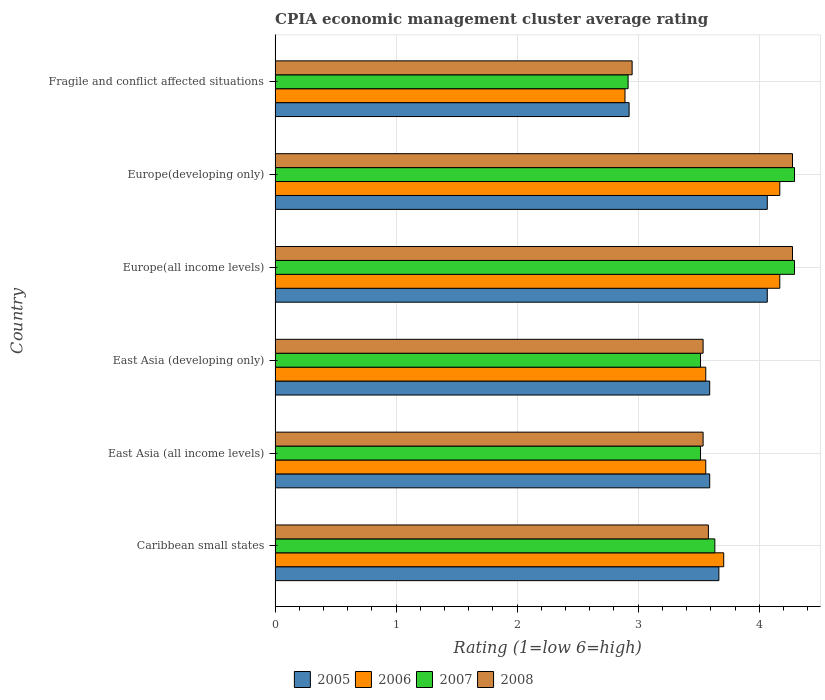How many different coloured bars are there?
Make the answer very short. 4. How many groups of bars are there?
Give a very brief answer. 6. Are the number of bars on each tick of the Y-axis equal?
Give a very brief answer. Yes. How many bars are there on the 4th tick from the top?
Your answer should be very brief. 4. How many bars are there on the 2nd tick from the bottom?
Make the answer very short. 4. What is the label of the 3rd group of bars from the top?
Provide a succinct answer. Europe(all income levels). In how many cases, is the number of bars for a given country not equal to the number of legend labels?
Make the answer very short. 0. What is the CPIA rating in 2008 in Europe(all income levels)?
Provide a succinct answer. 4.28. Across all countries, what is the maximum CPIA rating in 2005?
Keep it short and to the point. 4.07. Across all countries, what is the minimum CPIA rating in 2007?
Make the answer very short. 2.92. In which country was the CPIA rating in 2005 maximum?
Offer a very short reply. Europe(all income levels). In which country was the CPIA rating in 2008 minimum?
Give a very brief answer. Fragile and conflict affected situations. What is the total CPIA rating in 2008 in the graph?
Provide a short and direct response. 22.15. What is the difference between the CPIA rating in 2008 in Caribbean small states and the CPIA rating in 2007 in Europe(developing only)?
Make the answer very short. -0.71. What is the average CPIA rating in 2005 per country?
Offer a terse response. 3.65. What is the difference between the CPIA rating in 2006 and CPIA rating in 2005 in Caribbean small states?
Provide a succinct answer. 0.04. In how many countries, is the CPIA rating in 2008 greater than 3.6 ?
Provide a succinct answer. 2. What is the ratio of the CPIA rating in 2005 in East Asia (all income levels) to that in Europe(developing only)?
Ensure brevity in your answer.  0.88. Is the CPIA rating in 2006 in Caribbean small states less than that in Europe(developing only)?
Ensure brevity in your answer.  Yes. What is the difference between the highest and the lowest CPIA rating in 2008?
Keep it short and to the point. 1.33. Is the sum of the CPIA rating in 2006 in Europe(all income levels) and Fragile and conflict affected situations greater than the maximum CPIA rating in 2008 across all countries?
Offer a terse response. Yes. Is it the case that in every country, the sum of the CPIA rating in 2007 and CPIA rating in 2008 is greater than the CPIA rating in 2006?
Keep it short and to the point. Yes. Are all the bars in the graph horizontal?
Provide a succinct answer. Yes. How many countries are there in the graph?
Your response must be concise. 6. What is the difference between two consecutive major ticks on the X-axis?
Provide a succinct answer. 1. Are the values on the major ticks of X-axis written in scientific E-notation?
Offer a terse response. No. Does the graph contain grids?
Offer a terse response. Yes. Where does the legend appear in the graph?
Offer a very short reply. Bottom center. How many legend labels are there?
Your answer should be very brief. 4. How are the legend labels stacked?
Offer a very short reply. Horizontal. What is the title of the graph?
Make the answer very short. CPIA economic management cluster average rating. Does "2011" appear as one of the legend labels in the graph?
Keep it short and to the point. No. What is the label or title of the X-axis?
Give a very brief answer. Rating (1=low 6=high). What is the Rating (1=low 6=high) in 2005 in Caribbean small states?
Provide a succinct answer. 3.67. What is the Rating (1=low 6=high) in 2006 in Caribbean small states?
Your answer should be compact. 3.71. What is the Rating (1=low 6=high) in 2007 in Caribbean small states?
Provide a succinct answer. 3.63. What is the Rating (1=low 6=high) in 2008 in Caribbean small states?
Offer a terse response. 3.58. What is the Rating (1=low 6=high) in 2005 in East Asia (all income levels)?
Offer a very short reply. 3.59. What is the Rating (1=low 6=high) in 2006 in East Asia (all income levels)?
Offer a terse response. 3.56. What is the Rating (1=low 6=high) in 2007 in East Asia (all income levels)?
Ensure brevity in your answer.  3.52. What is the Rating (1=low 6=high) of 2008 in East Asia (all income levels)?
Your answer should be very brief. 3.54. What is the Rating (1=low 6=high) of 2005 in East Asia (developing only)?
Offer a very short reply. 3.59. What is the Rating (1=low 6=high) of 2006 in East Asia (developing only)?
Ensure brevity in your answer.  3.56. What is the Rating (1=low 6=high) in 2007 in East Asia (developing only)?
Offer a very short reply. 3.52. What is the Rating (1=low 6=high) of 2008 in East Asia (developing only)?
Provide a succinct answer. 3.54. What is the Rating (1=low 6=high) of 2005 in Europe(all income levels)?
Your answer should be compact. 4.07. What is the Rating (1=low 6=high) of 2006 in Europe(all income levels)?
Offer a terse response. 4.17. What is the Rating (1=low 6=high) of 2007 in Europe(all income levels)?
Your answer should be very brief. 4.29. What is the Rating (1=low 6=high) in 2008 in Europe(all income levels)?
Make the answer very short. 4.28. What is the Rating (1=low 6=high) of 2005 in Europe(developing only)?
Your answer should be very brief. 4.07. What is the Rating (1=low 6=high) of 2006 in Europe(developing only)?
Your answer should be very brief. 4.17. What is the Rating (1=low 6=high) of 2007 in Europe(developing only)?
Offer a very short reply. 4.29. What is the Rating (1=low 6=high) of 2008 in Europe(developing only)?
Your answer should be very brief. 4.28. What is the Rating (1=low 6=high) in 2005 in Fragile and conflict affected situations?
Keep it short and to the point. 2.92. What is the Rating (1=low 6=high) of 2006 in Fragile and conflict affected situations?
Your answer should be very brief. 2.89. What is the Rating (1=low 6=high) in 2007 in Fragile and conflict affected situations?
Provide a succinct answer. 2.92. What is the Rating (1=low 6=high) in 2008 in Fragile and conflict affected situations?
Provide a short and direct response. 2.95. Across all countries, what is the maximum Rating (1=low 6=high) in 2005?
Offer a very short reply. 4.07. Across all countries, what is the maximum Rating (1=low 6=high) in 2006?
Provide a short and direct response. 4.17. Across all countries, what is the maximum Rating (1=low 6=high) of 2007?
Provide a succinct answer. 4.29. Across all countries, what is the maximum Rating (1=low 6=high) of 2008?
Give a very brief answer. 4.28. Across all countries, what is the minimum Rating (1=low 6=high) of 2005?
Your answer should be compact. 2.92. Across all countries, what is the minimum Rating (1=low 6=high) of 2006?
Offer a very short reply. 2.89. Across all countries, what is the minimum Rating (1=low 6=high) of 2007?
Your answer should be very brief. 2.92. Across all countries, what is the minimum Rating (1=low 6=high) in 2008?
Ensure brevity in your answer.  2.95. What is the total Rating (1=low 6=high) in 2005 in the graph?
Your response must be concise. 21.91. What is the total Rating (1=low 6=high) of 2006 in the graph?
Offer a terse response. 22.05. What is the total Rating (1=low 6=high) in 2007 in the graph?
Your response must be concise. 22.16. What is the total Rating (1=low 6=high) of 2008 in the graph?
Your answer should be very brief. 22.15. What is the difference between the Rating (1=low 6=high) in 2005 in Caribbean small states and that in East Asia (all income levels)?
Your answer should be very brief. 0.08. What is the difference between the Rating (1=low 6=high) of 2006 in Caribbean small states and that in East Asia (all income levels)?
Provide a short and direct response. 0.15. What is the difference between the Rating (1=low 6=high) of 2007 in Caribbean small states and that in East Asia (all income levels)?
Your response must be concise. 0.12. What is the difference between the Rating (1=low 6=high) of 2008 in Caribbean small states and that in East Asia (all income levels)?
Give a very brief answer. 0.04. What is the difference between the Rating (1=low 6=high) of 2005 in Caribbean small states and that in East Asia (developing only)?
Keep it short and to the point. 0.08. What is the difference between the Rating (1=low 6=high) in 2006 in Caribbean small states and that in East Asia (developing only)?
Your response must be concise. 0.15. What is the difference between the Rating (1=low 6=high) of 2007 in Caribbean small states and that in East Asia (developing only)?
Offer a very short reply. 0.12. What is the difference between the Rating (1=low 6=high) in 2008 in Caribbean small states and that in East Asia (developing only)?
Provide a short and direct response. 0.04. What is the difference between the Rating (1=low 6=high) in 2006 in Caribbean small states and that in Europe(all income levels)?
Provide a succinct answer. -0.46. What is the difference between the Rating (1=low 6=high) of 2007 in Caribbean small states and that in Europe(all income levels)?
Your answer should be very brief. -0.66. What is the difference between the Rating (1=low 6=high) of 2008 in Caribbean small states and that in Europe(all income levels)?
Your response must be concise. -0.69. What is the difference between the Rating (1=low 6=high) of 2006 in Caribbean small states and that in Europe(developing only)?
Provide a short and direct response. -0.46. What is the difference between the Rating (1=low 6=high) of 2007 in Caribbean small states and that in Europe(developing only)?
Ensure brevity in your answer.  -0.66. What is the difference between the Rating (1=low 6=high) of 2008 in Caribbean small states and that in Europe(developing only)?
Keep it short and to the point. -0.69. What is the difference between the Rating (1=low 6=high) in 2005 in Caribbean small states and that in Fragile and conflict affected situations?
Make the answer very short. 0.74. What is the difference between the Rating (1=low 6=high) in 2006 in Caribbean small states and that in Fragile and conflict affected situations?
Make the answer very short. 0.82. What is the difference between the Rating (1=low 6=high) of 2007 in Caribbean small states and that in Fragile and conflict affected situations?
Provide a short and direct response. 0.72. What is the difference between the Rating (1=low 6=high) of 2008 in Caribbean small states and that in Fragile and conflict affected situations?
Keep it short and to the point. 0.63. What is the difference between the Rating (1=low 6=high) of 2006 in East Asia (all income levels) and that in East Asia (developing only)?
Make the answer very short. 0. What is the difference between the Rating (1=low 6=high) in 2007 in East Asia (all income levels) and that in East Asia (developing only)?
Offer a very short reply. 0. What is the difference between the Rating (1=low 6=high) of 2005 in East Asia (all income levels) and that in Europe(all income levels)?
Keep it short and to the point. -0.48. What is the difference between the Rating (1=low 6=high) of 2006 in East Asia (all income levels) and that in Europe(all income levels)?
Provide a succinct answer. -0.61. What is the difference between the Rating (1=low 6=high) in 2007 in East Asia (all income levels) and that in Europe(all income levels)?
Make the answer very short. -0.78. What is the difference between the Rating (1=low 6=high) in 2008 in East Asia (all income levels) and that in Europe(all income levels)?
Provide a succinct answer. -0.74. What is the difference between the Rating (1=low 6=high) of 2005 in East Asia (all income levels) and that in Europe(developing only)?
Provide a short and direct response. -0.48. What is the difference between the Rating (1=low 6=high) in 2006 in East Asia (all income levels) and that in Europe(developing only)?
Provide a succinct answer. -0.61. What is the difference between the Rating (1=low 6=high) of 2007 in East Asia (all income levels) and that in Europe(developing only)?
Offer a very short reply. -0.78. What is the difference between the Rating (1=low 6=high) of 2008 in East Asia (all income levels) and that in Europe(developing only)?
Provide a short and direct response. -0.74. What is the difference between the Rating (1=low 6=high) of 2005 in East Asia (all income levels) and that in Fragile and conflict affected situations?
Offer a terse response. 0.67. What is the difference between the Rating (1=low 6=high) of 2006 in East Asia (all income levels) and that in Fragile and conflict affected situations?
Give a very brief answer. 0.67. What is the difference between the Rating (1=low 6=high) of 2007 in East Asia (all income levels) and that in Fragile and conflict affected situations?
Keep it short and to the point. 0.6. What is the difference between the Rating (1=low 6=high) in 2008 in East Asia (all income levels) and that in Fragile and conflict affected situations?
Keep it short and to the point. 0.59. What is the difference between the Rating (1=low 6=high) in 2005 in East Asia (developing only) and that in Europe(all income levels)?
Keep it short and to the point. -0.48. What is the difference between the Rating (1=low 6=high) of 2006 in East Asia (developing only) and that in Europe(all income levels)?
Your answer should be compact. -0.61. What is the difference between the Rating (1=low 6=high) in 2007 in East Asia (developing only) and that in Europe(all income levels)?
Your answer should be very brief. -0.78. What is the difference between the Rating (1=low 6=high) of 2008 in East Asia (developing only) and that in Europe(all income levels)?
Offer a very short reply. -0.74. What is the difference between the Rating (1=low 6=high) in 2005 in East Asia (developing only) and that in Europe(developing only)?
Ensure brevity in your answer.  -0.48. What is the difference between the Rating (1=low 6=high) of 2006 in East Asia (developing only) and that in Europe(developing only)?
Give a very brief answer. -0.61. What is the difference between the Rating (1=low 6=high) in 2007 in East Asia (developing only) and that in Europe(developing only)?
Your answer should be compact. -0.78. What is the difference between the Rating (1=low 6=high) in 2008 in East Asia (developing only) and that in Europe(developing only)?
Make the answer very short. -0.74. What is the difference between the Rating (1=low 6=high) in 2005 in East Asia (developing only) and that in Fragile and conflict affected situations?
Provide a succinct answer. 0.67. What is the difference between the Rating (1=low 6=high) in 2006 in East Asia (developing only) and that in Fragile and conflict affected situations?
Provide a short and direct response. 0.67. What is the difference between the Rating (1=low 6=high) in 2007 in East Asia (developing only) and that in Fragile and conflict affected situations?
Ensure brevity in your answer.  0.6. What is the difference between the Rating (1=low 6=high) in 2008 in East Asia (developing only) and that in Fragile and conflict affected situations?
Your response must be concise. 0.59. What is the difference between the Rating (1=low 6=high) of 2005 in Europe(all income levels) and that in Europe(developing only)?
Ensure brevity in your answer.  0. What is the difference between the Rating (1=low 6=high) in 2008 in Europe(all income levels) and that in Europe(developing only)?
Make the answer very short. 0. What is the difference between the Rating (1=low 6=high) of 2005 in Europe(all income levels) and that in Fragile and conflict affected situations?
Ensure brevity in your answer.  1.14. What is the difference between the Rating (1=low 6=high) of 2006 in Europe(all income levels) and that in Fragile and conflict affected situations?
Make the answer very short. 1.28. What is the difference between the Rating (1=low 6=high) in 2007 in Europe(all income levels) and that in Fragile and conflict affected situations?
Your answer should be very brief. 1.38. What is the difference between the Rating (1=low 6=high) of 2008 in Europe(all income levels) and that in Fragile and conflict affected situations?
Ensure brevity in your answer.  1.32. What is the difference between the Rating (1=low 6=high) in 2005 in Europe(developing only) and that in Fragile and conflict affected situations?
Provide a short and direct response. 1.14. What is the difference between the Rating (1=low 6=high) in 2006 in Europe(developing only) and that in Fragile and conflict affected situations?
Provide a succinct answer. 1.28. What is the difference between the Rating (1=low 6=high) in 2007 in Europe(developing only) and that in Fragile and conflict affected situations?
Offer a terse response. 1.38. What is the difference between the Rating (1=low 6=high) in 2008 in Europe(developing only) and that in Fragile and conflict affected situations?
Provide a succinct answer. 1.32. What is the difference between the Rating (1=low 6=high) in 2005 in Caribbean small states and the Rating (1=low 6=high) in 2006 in East Asia (all income levels)?
Offer a very short reply. 0.11. What is the difference between the Rating (1=low 6=high) in 2005 in Caribbean small states and the Rating (1=low 6=high) in 2007 in East Asia (all income levels)?
Offer a terse response. 0.15. What is the difference between the Rating (1=low 6=high) in 2005 in Caribbean small states and the Rating (1=low 6=high) in 2008 in East Asia (all income levels)?
Provide a succinct answer. 0.13. What is the difference between the Rating (1=low 6=high) of 2006 in Caribbean small states and the Rating (1=low 6=high) of 2007 in East Asia (all income levels)?
Provide a short and direct response. 0.19. What is the difference between the Rating (1=low 6=high) of 2006 in Caribbean small states and the Rating (1=low 6=high) of 2008 in East Asia (all income levels)?
Make the answer very short. 0.17. What is the difference between the Rating (1=low 6=high) of 2007 in Caribbean small states and the Rating (1=low 6=high) of 2008 in East Asia (all income levels)?
Keep it short and to the point. 0.1. What is the difference between the Rating (1=low 6=high) of 2005 in Caribbean small states and the Rating (1=low 6=high) of 2006 in East Asia (developing only)?
Offer a terse response. 0.11. What is the difference between the Rating (1=low 6=high) in 2005 in Caribbean small states and the Rating (1=low 6=high) in 2007 in East Asia (developing only)?
Your answer should be compact. 0.15. What is the difference between the Rating (1=low 6=high) of 2005 in Caribbean small states and the Rating (1=low 6=high) of 2008 in East Asia (developing only)?
Your response must be concise. 0.13. What is the difference between the Rating (1=low 6=high) in 2006 in Caribbean small states and the Rating (1=low 6=high) in 2007 in East Asia (developing only)?
Provide a succinct answer. 0.19. What is the difference between the Rating (1=low 6=high) in 2006 in Caribbean small states and the Rating (1=low 6=high) in 2008 in East Asia (developing only)?
Offer a terse response. 0.17. What is the difference between the Rating (1=low 6=high) in 2007 in Caribbean small states and the Rating (1=low 6=high) in 2008 in East Asia (developing only)?
Your answer should be compact. 0.1. What is the difference between the Rating (1=low 6=high) in 2005 in Caribbean small states and the Rating (1=low 6=high) in 2006 in Europe(all income levels)?
Your answer should be compact. -0.5. What is the difference between the Rating (1=low 6=high) in 2005 in Caribbean small states and the Rating (1=low 6=high) in 2007 in Europe(all income levels)?
Your answer should be very brief. -0.62. What is the difference between the Rating (1=low 6=high) in 2005 in Caribbean small states and the Rating (1=low 6=high) in 2008 in Europe(all income levels)?
Your answer should be compact. -0.61. What is the difference between the Rating (1=low 6=high) in 2006 in Caribbean small states and the Rating (1=low 6=high) in 2007 in Europe(all income levels)?
Make the answer very short. -0.58. What is the difference between the Rating (1=low 6=high) in 2006 in Caribbean small states and the Rating (1=low 6=high) in 2008 in Europe(all income levels)?
Offer a terse response. -0.57. What is the difference between the Rating (1=low 6=high) in 2007 in Caribbean small states and the Rating (1=low 6=high) in 2008 in Europe(all income levels)?
Your answer should be very brief. -0.64. What is the difference between the Rating (1=low 6=high) in 2005 in Caribbean small states and the Rating (1=low 6=high) in 2006 in Europe(developing only)?
Your answer should be very brief. -0.5. What is the difference between the Rating (1=low 6=high) in 2005 in Caribbean small states and the Rating (1=low 6=high) in 2007 in Europe(developing only)?
Offer a terse response. -0.62. What is the difference between the Rating (1=low 6=high) of 2005 in Caribbean small states and the Rating (1=low 6=high) of 2008 in Europe(developing only)?
Your response must be concise. -0.61. What is the difference between the Rating (1=low 6=high) of 2006 in Caribbean small states and the Rating (1=low 6=high) of 2007 in Europe(developing only)?
Keep it short and to the point. -0.58. What is the difference between the Rating (1=low 6=high) of 2006 in Caribbean small states and the Rating (1=low 6=high) of 2008 in Europe(developing only)?
Your answer should be very brief. -0.57. What is the difference between the Rating (1=low 6=high) in 2007 in Caribbean small states and the Rating (1=low 6=high) in 2008 in Europe(developing only)?
Provide a succinct answer. -0.64. What is the difference between the Rating (1=low 6=high) of 2005 in Caribbean small states and the Rating (1=low 6=high) of 2006 in Fragile and conflict affected situations?
Keep it short and to the point. 0.78. What is the difference between the Rating (1=low 6=high) in 2005 in Caribbean small states and the Rating (1=low 6=high) in 2007 in Fragile and conflict affected situations?
Provide a short and direct response. 0.75. What is the difference between the Rating (1=low 6=high) in 2005 in Caribbean small states and the Rating (1=low 6=high) in 2008 in Fragile and conflict affected situations?
Ensure brevity in your answer.  0.72. What is the difference between the Rating (1=low 6=high) in 2006 in Caribbean small states and the Rating (1=low 6=high) in 2007 in Fragile and conflict affected situations?
Ensure brevity in your answer.  0.79. What is the difference between the Rating (1=low 6=high) of 2006 in Caribbean small states and the Rating (1=low 6=high) of 2008 in Fragile and conflict affected situations?
Keep it short and to the point. 0.76. What is the difference between the Rating (1=low 6=high) in 2007 in Caribbean small states and the Rating (1=low 6=high) in 2008 in Fragile and conflict affected situations?
Provide a short and direct response. 0.68. What is the difference between the Rating (1=low 6=high) of 2005 in East Asia (all income levels) and the Rating (1=low 6=high) of 2006 in East Asia (developing only)?
Provide a short and direct response. 0.03. What is the difference between the Rating (1=low 6=high) in 2005 in East Asia (all income levels) and the Rating (1=low 6=high) in 2007 in East Asia (developing only)?
Offer a terse response. 0.08. What is the difference between the Rating (1=low 6=high) of 2005 in East Asia (all income levels) and the Rating (1=low 6=high) of 2008 in East Asia (developing only)?
Give a very brief answer. 0.05. What is the difference between the Rating (1=low 6=high) in 2006 in East Asia (all income levels) and the Rating (1=low 6=high) in 2007 in East Asia (developing only)?
Your answer should be very brief. 0.04. What is the difference between the Rating (1=low 6=high) of 2006 in East Asia (all income levels) and the Rating (1=low 6=high) of 2008 in East Asia (developing only)?
Provide a short and direct response. 0.02. What is the difference between the Rating (1=low 6=high) of 2007 in East Asia (all income levels) and the Rating (1=low 6=high) of 2008 in East Asia (developing only)?
Provide a succinct answer. -0.02. What is the difference between the Rating (1=low 6=high) of 2005 in East Asia (all income levels) and the Rating (1=low 6=high) of 2006 in Europe(all income levels)?
Give a very brief answer. -0.58. What is the difference between the Rating (1=low 6=high) in 2005 in East Asia (all income levels) and the Rating (1=low 6=high) in 2007 in Europe(all income levels)?
Give a very brief answer. -0.7. What is the difference between the Rating (1=low 6=high) of 2005 in East Asia (all income levels) and the Rating (1=low 6=high) of 2008 in Europe(all income levels)?
Keep it short and to the point. -0.68. What is the difference between the Rating (1=low 6=high) in 2006 in East Asia (all income levels) and the Rating (1=low 6=high) in 2007 in Europe(all income levels)?
Offer a terse response. -0.73. What is the difference between the Rating (1=low 6=high) of 2006 in East Asia (all income levels) and the Rating (1=low 6=high) of 2008 in Europe(all income levels)?
Your response must be concise. -0.72. What is the difference between the Rating (1=low 6=high) in 2007 in East Asia (all income levels) and the Rating (1=low 6=high) in 2008 in Europe(all income levels)?
Provide a short and direct response. -0.76. What is the difference between the Rating (1=low 6=high) of 2005 in East Asia (all income levels) and the Rating (1=low 6=high) of 2006 in Europe(developing only)?
Offer a terse response. -0.58. What is the difference between the Rating (1=low 6=high) in 2005 in East Asia (all income levels) and the Rating (1=low 6=high) in 2007 in Europe(developing only)?
Provide a short and direct response. -0.7. What is the difference between the Rating (1=low 6=high) in 2005 in East Asia (all income levels) and the Rating (1=low 6=high) in 2008 in Europe(developing only)?
Provide a short and direct response. -0.68. What is the difference between the Rating (1=low 6=high) in 2006 in East Asia (all income levels) and the Rating (1=low 6=high) in 2007 in Europe(developing only)?
Keep it short and to the point. -0.73. What is the difference between the Rating (1=low 6=high) of 2006 in East Asia (all income levels) and the Rating (1=low 6=high) of 2008 in Europe(developing only)?
Make the answer very short. -0.72. What is the difference between the Rating (1=low 6=high) of 2007 in East Asia (all income levels) and the Rating (1=low 6=high) of 2008 in Europe(developing only)?
Offer a terse response. -0.76. What is the difference between the Rating (1=low 6=high) in 2005 in East Asia (all income levels) and the Rating (1=low 6=high) in 2006 in Fragile and conflict affected situations?
Your answer should be very brief. 0.7. What is the difference between the Rating (1=low 6=high) in 2005 in East Asia (all income levels) and the Rating (1=low 6=high) in 2007 in Fragile and conflict affected situations?
Your answer should be very brief. 0.67. What is the difference between the Rating (1=low 6=high) in 2005 in East Asia (all income levels) and the Rating (1=low 6=high) in 2008 in Fragile and conflict affected situations?
Make the answer very short. 0.64. What is the difference between the Rating (1=low 6=high) of 2006 in East Asia (all income levels) and the Rating (1=low 6=high) of 2007 in Fragile and conflict affected situations?
Make the answer very short. 0.64. What is the difference between the Rating (1=low 6=high) in 2006 in East Asia (all income levels) and the Rating (1=low 6=high) in 2008 in Fragile and conflict affected situations?
Your answer should be very brief. 0.61. What is the difference between the Rating (1=low 6=high) in 2007 in East Asia (all income levels) and the Rating (1=low 6=high) in 2008 in Fragile and conflict affected situations?
Offer a terse response. 0.57. What is the difference between the Rating (1=low 6=high) of 2005 in East Asia (developing only) and the Rating (1=low 6=high) of 2006 in Europe(all income levels)?
Provide a succinct answer. -0.58. What is the difference between the Rating (1=low 6=high) of 2005 in East Asia (developing only) and the Rating (1=low 6=high) of 2007 in Europe(all income levels)?
Keep it short and to the point. -0.7. What is the difference between the Rating (1=low 6=high) in 2005 in East Asia (developing only) and the Rating (1=low 6=high) in 2008 in Europe(all income levels)?
Provide a short and direct response. -0.68. What is the difference between the Rating (1=low 6=high) of 2006 in East Asia (developing only) and the Rating (1=low 6=high) of 2007 in Europe(all income levels)?
Provide a succinct answer. -0.73. What is the difference between the Rating (1=low 6=high) of 2006 in East Asia (developing only) and the Rating (1=low 6=high) of 2008 in Europe(all income levels)?
Offer a very short reply. -0.72. What is the difference between the Rating (1=low 6=high) in 2007 in East Asia (developing only) and the Rating (1=low 6=high) in 2008 in Europe(all income levels)?
Provide a short and direct response. -0.76. What is the difference between the Rating (1=low 6=high) in 2005 in East Asia (developing only) and the Rating (1=low 6=high) in 2006 in Europe(developing only)?
Keep it short and to the point. -0.58. What is the difference between the Rating (1=low 6=high) of 2005 in East Asia (developing only) and the Rating (1=low 6=high) of 2007 in Europe(developing only)?
Provide a succinct answer. -0.7. What is the difference between the Rating (1=low 6=high) of 2005 in East Asia (developing only) and the Rating (1=low 6=high) of 2008 in Europe(developing only)?
Make the answer very short. -0.68. What is the difference between the Rating (1=low 6=high) in 2006 in East Asia (developing only) and the Rating (1=low 6=high) in 2007 in Europe(developing only)?
Ensure brevity in your answer.  -0.73. What is the difference between the Rating (1=low 6=high) in 2006 in East Asia (developing only) and the Rating (1=low 6=high) in 2008 in Europe(developing only)?
Offer a terse response. -0.72. What is the difference between the Rating (1=low 6=high) in 2007 in East Asia (developing only) and the Rating (1=low 6=high) in 2008 in Europe(developing only)?
Your response must be concise. -0.76. What is the difference between the Rating (1=low 6=high) of 2005 in East Asia (developing only) and the Rating (1=low 6=high) of 2007 in Fragile and conflict affected situations?
Keep it short and to the point. 0.67. What is the difference between the Rating (1=low 6=high) of 2005 in East Asia (developing only) and the Rating (1=low 6=high) of 2008 in Fragile and conflict affected situations?
Make the answer very short. 0.64. What is the difference between the Rating (1=low 6=high) in 2006 in East Asia (developing only) and the Rating (1=low 6=high) in 2007 in Fragile and conflict affected situations?
Keep it short and to the point. 0.64. What is the difference between the Rating (1=low 6=high) of 2006 in East Asia (developing only) and the Rating (1=low 6=high) of 2008 in Fragile and conflict affected situations?
Offer a terse response. 0.61. What is the difference between the Rating (1=low 6=high) of 2007 in East Asia (developing only) and the Rating (1=low 6=high) of 2008 in Fragile and conflict affected situations?
Your answer should be compact. 0.57. What is the difference between the Rating (1=low 6=high) in 2005 in Europe(all income levels) and the Rating (1=low 6=high) in 2006 in Europe(developing only)?
Ensure brevity in your answer.  -0.1. What is the difference between the Rating (1=low 6=high) of 2005 in Europe(all income levels) and the Rating (1=low 6=high) of 2007 in Europe(developing only)?
Provide a succinct answer. -0.23. What is the difference between the Rating (1=low 6=high) in 2005 in Europe(all income levels) and the Rating (1=low 6=high) in 2008 in Europe(developing only)?
Give a very brief answer. -0.21. What is the difference between the Rating (1=low 6=high) of 2006 in Europe(all income levels) and the Rating (1=low 6=high) of 2007 in Europe(developing only)?
Offer a very short reply. -0.12. What is the difference between the Rating (1=low 6=high) of 2006 in Europe(all income levels) and the Rating (1=low 6=high) of 2008 in Europe(developing only)?
Provide a short and direct response. -0.1. What is the difference between the Rating (1=low 6=high) of 2007 in Europe(all income levels) and the Rating (1=low 6=high) of 2008 in Europe(developing only)?
Ensure brevity in your answer.  0.02. What is the difference between the Rating (1=low 6=high) of 2005 in Europe(all income levels) and the Rating (1=low 6=high) of 2006 in Fragile and conflict affected situations?
Keep it short and to the point. 1.18. What is the difference between the Rating (1=low 6=high) of 2005 in Europe(all income levels) and the Rating (1=low 6=high) of 2007 in Fragile and conflict affected situations?
Provide a short and direct response. 1.15. What is the difference between the Rating (1=low 6=high) of 2005 in Europe(all income levels) and the Rating (1=low 6=high) of 2008 in Fragile and conflict affected situations?
Ensure brevity in your answer.  1.12. What is the difference between the Rating (1=low 6=high) of 2006 in Europe(all income levels) and the Rating (1=low 6=high) of 2007 in Fragile and conflict affected situations?
Give a very brief answer. 1.25. What is the difference between the Rating (1=low 6=high) in 2006 in Europe(all income levels) and the Rating (1=low 6=high) in 2008 in Fragile and conflict affected situations?
Your answer should be compact. 1.22. What is the difference between the Rating (1=low 6=high) of 2007 in Europe(all income levels) and the Rating (1=low 6=high) of 2008 in Fragile and conflict affected situations?
Offer a terse response. 1.34. What is the difference between the Rating (1=low 6=high) in 2005 in Europe(developing only) and the Rating (1=low 6=high) in 2006 in Fragile and conflict affected situations?
Offer a very short reply. 1.18. What is the difference between the Rating (1=low 6=high) of 2005 in Europe(developing only) and the Rating (1=low 6=high) of 2007 in Fragile and conflict affected situations?
Offer a terse response. 1.15. What is the difference between the Rating (1=low 6=high) of 2005 in Europe(developing only) and the Rating (1=low 6=high) of 2008 in Fragile and conflict affected situations?
Provide a short and direct response. 1.12. What is the difference between the Rating (1=low 6=high) of 2006 in Europe(developing only) and the Rating (1=low 6=high) of 2007 in Fragile and conflict affected situations?
Offer a terse response. 1.25. What is the difference between the Rating (1=low 6=high) of 2006 in Europe(developing only) and the Rating (1=low 6=high) of 2008 in Fragile and conflict affected situations?
Provide a short and direct response. 1.22. What is the difference between the Rating (1=low 6=high) in 2007 in Europe(developing only) and the Rating (1=low 6=high) in 2008 in Fragile and conflict affected situations?
Give a very brief answer. 1.34. What is the average Rating (1=low 6=high) of 2005 per country?
Offer a very short reply. 3.65. What is the average Rating (1=low 6=high) of 2006 per country?
Provide a succinct answer. 3.68. What is the average Rating (1=low 6=high) in 2007 per country?
Your response must be concise. 3.69. What is the average Rating (1=low 6=high) in 2008 per country?
Your answer should be compact. 3.69. What is the difference between the Rating (1=low 6=high) in 2005 and Rating (1=low 6=high) in 2006 in Caribbean small states?
Offer a terse response. -0.04. What is the difference between the Rating (1=low 6=high) of 2005 and Rating (1=low 6=high) of 2008 in Caribbean small states?
Make the answer very short. 0.09. What is the difference between the Rating (1=low 6=high) in 2006 and Rating (1=low 6=high) in 2007 in Caribbean small states?
Give a very brief answer. 0.07. What is the difference between the Rating (1=low 6=high) in 2006 and Rating (1=low 6=high) in 2008 in Caribbean small states?
Offer a very short reply. 0.13. What is the difference between the Rating (1=low 6=high) of 2007 and Rating (1=low 6=high) of 2008 in Caribbean small states?
Offer a very short reply. 0.05. What is the difference between the Rating (1=low 6=high) in 2005 and Rating (1=low 6=high) in 2006 in East Asia (all income levels)?
Provide a succinct answer. 0.03. What is the difference between the Rating (1=low 6=high) of 2005 and Rating (1=low 6=high) of 2007 in East Asia (all income levels)?
Your answer should be very brief. 0.08. What is the difference between the Rating (1=low 6=high) of 2005 and Rating (1=low 6=high) of 2008 in East Asia (all income levels)?
Offer a very short reply. 0.05. What is the difference between the Rating (1=low 6=high) in 2006 and Rating (1=low 6=high) in 2007 in East Asia (all income levels)?
Provide a succinct answer. 0.04. What is the difference between the Rating (1=low 6=high) in 2006 and Rating (1=low 6=high) in 2008 in East Asia (all income levels)?
Give a very brief answer. 0.02. What is the difference between the Rating (1=low 6=high) of 2007 and Rating (1=low 6=high) of 2008 in East Asia (all income levels)?
Offer a very short reply. -0.02. What is the difference between the Rating (1=low 6=high) in 2005 and Rating (1=low 6=high) in 2006 in East Asia (developing only)?
Provide a short and direct response. 0.03. What is the difference between the Rating (1=low 6=high) in 2005 and Rating (1=low 6=high) in 2007 in East Asia (developing only)?
Ensure brevity in your answer.  0.08. What is the difference between the Rating (1=low 6=high) of 2005 and Rating (1=low 6=high) of 2008 in East Asia (developing only)?
Ensure brevity in your answer.  0.05. What is the difference between the Rating (1=low 6=high) in 2006 and Rating (1=low 6=high) in 2007 in East Asia (developing only)?
Provide a short and direct response. 0.04. What is the difference between the Rating (1=low 6=high) of 2006 and Rating (1=low 6=high) of 2008 in East Asia (developing only)?
Provide a succinct answer. 0.02. What is the difference between the Rating (1=low 6=high) of 2007 and Rating (1=low 6=high) of 2008 in East Asia (developing only)?
Your response must be concise. -0.02. What is the difference between the Rating (1=low 6=high) in 2005 and Rating (1=low 6=high) in 2006 in Europe(all income levels)?
Your answer should be compact. -0.1. What is the difference between the Rating (1=low 6=high) of 2005 and Rating (1=low 6=high) of 2007 in Europe(all income levels)?
Give a very brief answer. -0.23. What is the difference between the Rating (1=low 6=high) in 2005 and Rating (1=low 6=high) in 2008 in Europe(all income levels)?
Ensure brevity in your answer.  -0.21. What is the difference between the Rating (1=low 6=high) of 2006 and Rating (1=low 6=high) of 2007 in Europe(all income levels)?
Your response must be concise. -0.12. What is the difference between the Rating (1=low 6=high) of 2006 and Rating (1=low 6=high) of 2008 in Europe(all income levels)?
Keep it short and to the point. -0.1. What is the difference between the Rating (1=low 6=high) in 2007 and Rating (1=low 6=high) in 2008 in Europe(all income levels)?
Offer a very short reply. 0.02. What is the difference between the Rating (1=low 6=high) in 2005 and Rating (1=low 6=high) in 2006 in Europe(developing only)?
Provide a succinct answer. -0.1. What is the difference between the Rating (1=low 6=high) in 2005 and Rating (1=low 6=high) in 2007 in Europe(developing only)?
Give a very brief answer. -0.23. What is the difference between the Rating (1=low 6=high) in 2005 and Rating (1=low 6=high) in 2008 in Europe(developing only)?
Offer a very short reply. -0.21. What is the difference between the Rating (1=low 6=high) of 2006 and Rating (1=low 6=high) of 2007 in Europe(developing only)?
Provide a succinct answer. -0.12. What is the difference between the Rating (1=low 6=high) of 2006 and Rating (1=low 6=high) of 2008 in Europe(developing only)?
Offer a terse response. -0.1. What is the difference between the Rating (1=low 6=high) of 2007 and Rating (1=low 6=high) of 2008 in Europe(developing only)?
Your answer should be compact. 0.02. What is the difference between the Rating (1=low 6=high) in 2005 and Rating (1=low 6=high) in 2006 in Fragile and conflict affected situations?
Ensure brevity in your answer.  0.03. What is the difference between the Rating (1=low 6=high) in 2005 and Rating (1=low 6=high) in 2007 in Fragile and conflict affected situations?
Offer a terse response. 0.01. What is the difference between the Rating (1=low 6=high) in 2005 and Rating (1=low 6=high) in 2008 in Fragile and conflict affected situations?
Make the answer very short. -0.03. What is the difference between the Rating (1=low 6=high) in 2006 and Rating (1=low 6=high) in 2007 in Fragile and conflict affected situations?
Your response must be concise. -0.03. What is the difference between the Rating (1=low 6=high) of 2006 and Rating (1=low 6=high) of 2008 in Fragile and conflict affected situations?
Your response must be concise. -0.06. What is the difference between the Rating (1=low 6=high) of 2007 and Rating (1=low 6=high) of 2008 in Fragile and conflict affected situations?
Offer a very short reply. -0.03. What is the ratio of the Rating (1=low 6=high) in 2005 in Caribbean small states to that in East Asia (all income levels)?
Offer a very short reply. 1.02. What is the ratio of the Rating (1=low 6=high) in 2006 in Caribbean small states to that in East Asia (all income levels)?
Offer a terse response. 1.04. What is the ratio of the Rating (1=low 6=high) in 2007 in Caribbean small states to that in East Asia (all income levels)?
Ensure brevity in your answer.  1.03. What is the ratio of the Rating (1=low 6=high) in 2008 in Caribbean small states to that in East Asia (all income levels)?
Offer a very short reply. 1.01. What is the ratio of the Rating (1=low 6=high) in 2005 in Caribbean small states to that in East Asia (developing only)?
Your response must be concise. 1.02. What is the ratio of the Rating (1=low 6=high) of 2006 in Caribbean small states to that in East Asia (developing only)?
Keep it short and to the point. 1.04. What is the ratio of the Rating (1=low 6=high) of 2007 in Caribbean small states to that in East Asia (developing only)?
Provide a succinct answer. 1.03. What is the ratio of the Rating (1=low 6=high) of 2008 in Caribbean small states to that in East Asia (developing only)?
Provide a short and direct response. 1.01. What is the ratio of the Rating (1=low 6=high) of 2005 in Caribbean small states to that in Europe(all income levels)?
Provide a succinct answer. 0.9. What is the ratio of the Rating (1=low 6=high) of 2006 in Caribbean small states to that in Europe(all income levels)?
Give a very brief answer. 0.89. What is the ratio of the Rating (1=low 6=high) of 2007 in Caribbean small states to that in Europe(all income levels)?
Offer a very short reply. 0.85. What is the ratio of the Rating (1=low 6=high) in 2008 in Caribbean small states to that in Europe(all income levels)?
Offer a very short reply. 0.84. What is the ratio of the Rating (1=low 6=high) in 2005 in Caribbean small states to that in Europe(developing only)?
Provide a short and direct response. 0.9. What is the ratio of the Rating (1=low 6=high) in 2006 in Caribbean small states to that in Europe(developing only)?
Offer a very short reply. 0.89. What is the ratio of the Rating (1=low 6=high) in 2007 in Caribbean small states to that in Europe(developing only)?
Make the answer very short. 0.85. What is the ratio of the Rating (1=low 6=high) in 2008 in Caribbean small states to that in Europe(developing only)?
Offer a terse response. 0.84. What is the ratio of the Rating (1=low 6=high) in 2005 in Caribbean small states to that in Fragile and conflict affected situations?
Provide a short and direct response. 1.25. What is the ratio of the Rating (1=low 6=high) of 2006 in Caribbean small states to that in Fragile and conflict affected situations?
Keep it short and to the point. 1.28. What is the ratio of the Rating (1=low 6=high) in 2007 in Caribbean small states to that in Fragile and conflict affected situations?
Your answer should be very brief. 1.25. What is the ratio of the Rating (1=low 6=high) in 2008 in Caribbean small states to that in Fragile and conflict affected situations?
Ensure brevity in your answer.  1.21. What is the ratio of the Rating (1=low 6=high) in 2005 in East Asia (all income levels) to that in Europe(all income levels)?
Make the answer very short. 0.88. What is the ratio of the Rating (1=low 6=high) of 2006 in East Asia (all income levels) to that in Europe(all income levels)?
Offer a very short reply. 0.85. What is the ratio of the Rating (1=low 6=high) in 2007 in East Asia (all income levels) to that in Europe(all income levels)?
Provide a succinct answer. 0.82. What is the ratio of the Rating (1=low 6=high) of 2008 in East Asia (all income levels) to that in Europe(all income levels)?
Offer a terse response. 0.83. What is the ratio of the Rating (1=low 6=high) in 2005 in East Asia (all income levels) to that in Europe(developing only)?
Your answer should be compact. 0.88. What is the ratio of the Rating (1=low 6=high) in 2006 in East Asia (all income levels) to that in Europe(developing only)?
Make the answer very short. 0.85. What is the ratio of the Rating (1=low 6=high) in 2007 in East Asia (all income levels) to that in Europe(developing only)?
Offer a terse response. 0.82. What is the ratio of the Rating (1=low 6=high) in 2008 in East Asia (all income levels) to that in Europe(developing only)?
Provide a short and direct response. 0.83. What is the ratio of the Rating (1=low 6=high) of 2005 in East Asia (all income levels) to that in Fragile and conflict affected situations?
Your answer should be compact. 1.23. What is the ratio of the Rating (1=low 6=high) of 2006 in East Asia (all income levels) to that in Fragile and conflict affected situations?
Make the answer very short. 1.23. What is the ratio of the Rating (1=low 6=high) in 2007 in East Asia (all income levels) to that in Fragile and conflict affected situations?
Your answer should be very brief. 1.21. What is the ratio of the Rating (1=low 6=high) in 2008 in East Asia (all income levels) to that in Fragile and conflict affected situations?
Offer a terse response. 1.2. What is the ratio of the Rating (1=low 6=high) of 2005 in East Asia (developing only) to that in Europe(all income levels)?
Offer a terse response. 0.88. What is the ratio of the Rating (1=low 6=high) of 2006 in East Asia (developing only) to that in Europe(all income levels)?
Provide a short and direct response. 0.85. What is the ratio of the Rating (1=low 6=high) in 2007 in East Asia (developing only) to that in Europe(all income levels)?
Your answer should be very brief. 0.82. What is the ratio of the Rating (1=low 6=high) in 2008 in East Asia (developing only) to that in Europe(all income levels)?
Your response must be concise. 0.83. What is the ratio of the Rating (1=low 6=high) in 2005 in East Asia (developing only) to that in Europe(developing only)?
Give a very brief answer. 0.88. What is the ratio of the Rating (1=low 6=high) in 2006 in East Asia (developing only) to that in Europe(developing only)?
Ensure brevity in your answer.  0.85. What is the ratio of the Rating (1=low 6=high) in 2007 in East Asia (developing only) to that in Europe(developing only)?
Offer a very short reply. 0.82. What is the ratio of the Rating (1=low 6=high) in 2008 in East Asia (developing only) to that in Europe(developing only)?
Your response must be concise. 0.83. What is the ratio of the Rating (1=low 6=high) of 2005 in East Asia (developing only) to that in Fragile and conflict affected situations?
Your response must be concise. 1.23. What is the ratio of the Rating (1=low 6=high) in 2006 in East Asia (developing only) to that in Fragile and conflict affected situations?
Offer a terse response. 1.23. What is the ratio of the Rating (1=low 6=high) in 2007 in East Asia (developing only) to that in Fragile and conflict affected situations?
Keep it short and to the point. 1.21. What is the ratio of the Rating (1=low 6=high) in 2008 in East Asia (developing only) to that in Fragile and conflict affected situations?
Give a very brief answer. 1.2. What is the ratio of the Rating (1=low 6=high) in 2005 in Europe(all income levels) to that in Europe(developing only)?
Give a very brief answer. 1. What is the ratio of the Rating (1=low 6=high) of 2007 in Europe(all income levels) to that in Europe(developing only)?
Offer a terse response. 1. What is the ratio of the Rating (1=low 6=high) of 2005 in Europe(all income levels) to that in Fragile and conflict affected situations?
Give a very brief answer. 1.39. What is the ratio of the Rating (1=low 6=high) of 2006 in Europe(all income levels) to that in Fragile and conflict affected situations?
Keep it short and to the point. 1.44. What is the ratio of the Rating (1=low 6=high) of 2007 in Europe(all income levels) to that in Fragile and conflict affected situations?
Give a very brief answer. 1.47. What is the ratio of the Rating (1=low 6=high) in 2008 in Europe(all income levels) to that in Fragile and conflict affected situations?
Provide a succinct answer. 1.45. What is the ratio of the Rating (1=low 6=high) of 2005 in Europe(developing only) to that in Fragile and conflict affected situations?
Your response must be concise. 1.39. What is the ratio of the Rating (1=low 6=high) of 2006 in Europe(developing only) to that in Fragile and conflict affected situations?
Offer a very short reply. 1.44. What is the ratio of the Rating (1=low 6=high) in 2007 in Europe(developing only) to that in Fragile and conflict affected situations?
Keep it short and to the point. 1.47. What is the ratio of the Rating (1=low 6=high) of 2008 in Europe(developing only) to that in Fragile and conflict affected situations?
Offer a very short reply. 1.45. What is the difference between the highest and the second highest Rating (1=low 6=high) in 2005?
Ensure brevity in your answer.  0. What is the difference between the highest and the second highest Rating (1=low 6=high) in 2007?
Keep it short and to the point. 0. What is the difference between the highest and the second highest Rating (1=low 6=high) of 2008?
Make the answer very short. 0. What is the difference between the highest and the lowest Rating (1=low 6=high) in 2005?
Offer a very short reply. 1.14. What is the difference between the highest and the lowest Rating (1=low 6=high) in 2006?
Offer a terse response. 1.28. What is the difference between the highest and the lowest Rating (1=low 6=high) of 2007?
Provide a short and direct response. 1.38. What is the difference between the highest and the lowest Rating (1=low 6=high) in 2008?
Give a very brief answer. 1.32. 